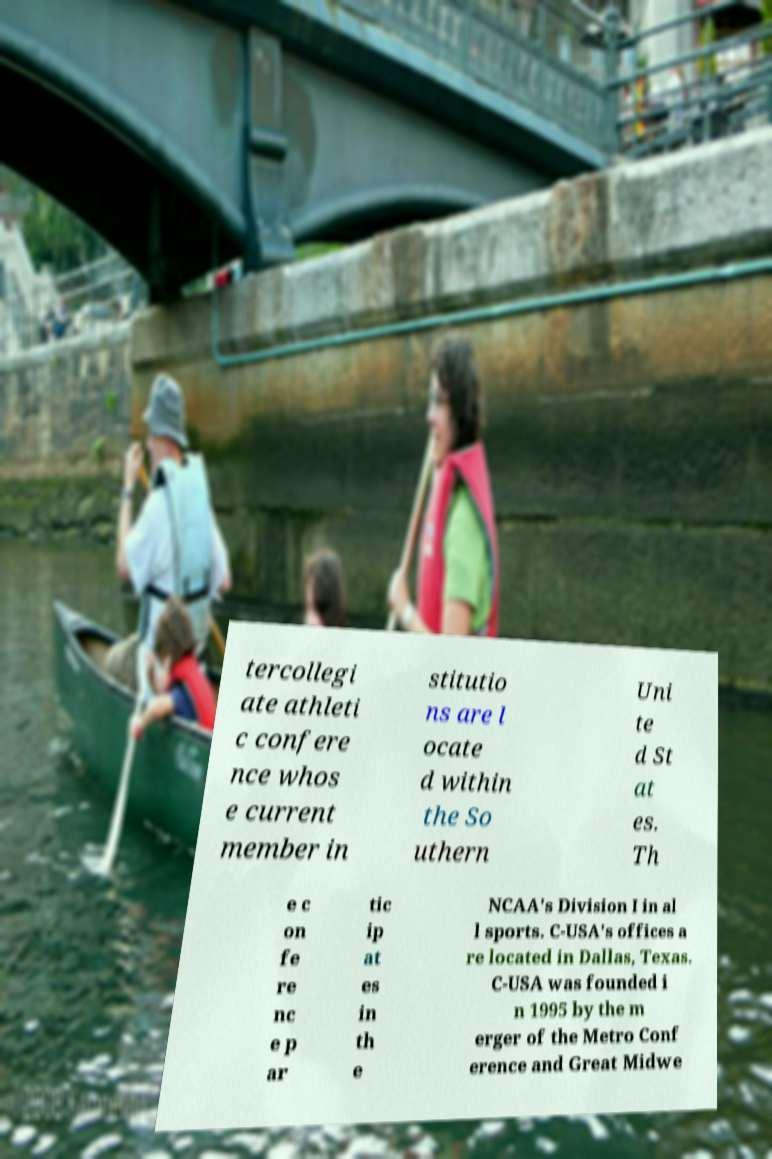Please identify and transcribe the text found in this image. tercollegi ate athleti c confere nce whos e current member in stitutio ns are l ocate d within the So uthern Uni te d St at es. Th e c on fe re nc e p ar tic ip at es in th e NCAA's Division I in al l sports. C-USA's offices a re located in Dallas, Texas. C-USA was founded i n 1995 by the m erger of the Metro Conf erence and Great Midwe 